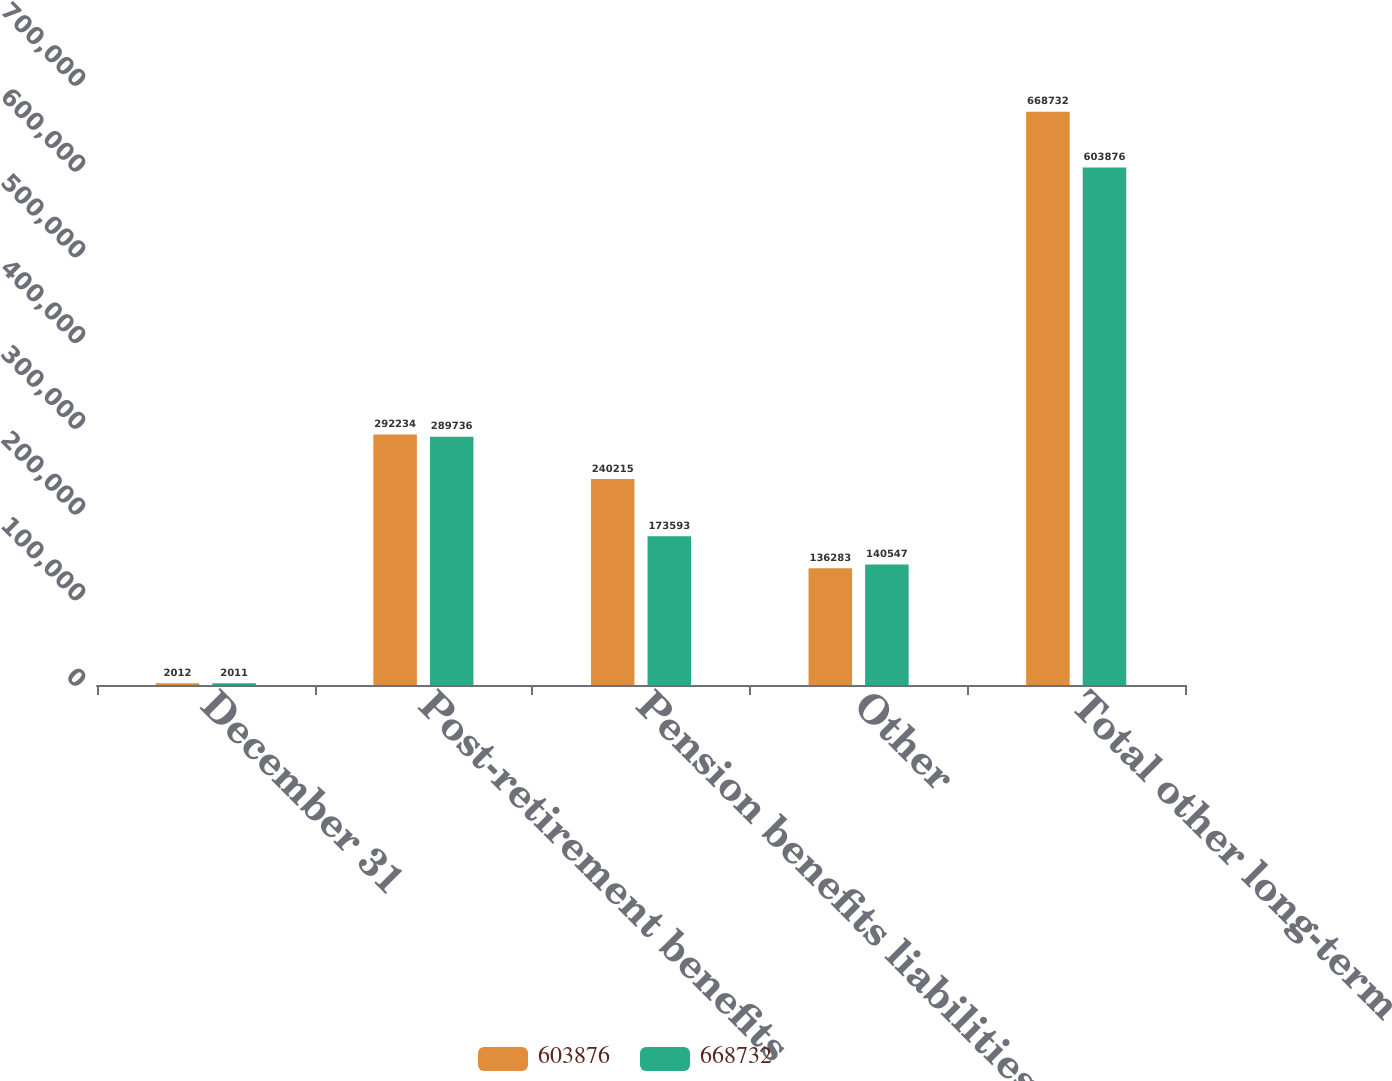Convert chart. <chart><loc_0><loc_0><loc_500><loc_500><stacked_bar_chart><ecel><fcel>December 31<fcel>Post-retirement benefits<fcel>Pension benefits liabilities<fcel>Other<fcel>Total other long-term<nl><fcel>603876<fcel>2012<fcel>292234<fcel>240215<fcel>136283<fcel>668732<nl><fcel>668732<fcel>2011<fcel>289736<fcel>173593<fcel>140547<fcel>603876<nl></chart> 